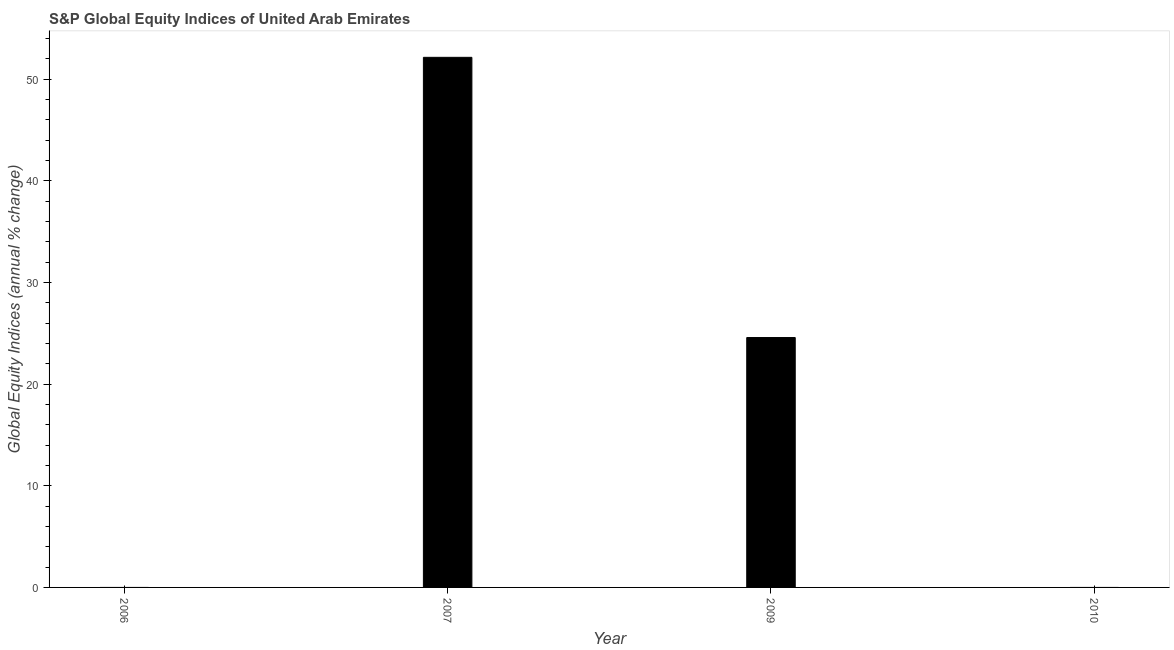Does the graph contain any zero values?
Offer a terse response. Yes. What is the title of the graph?
Your answer should be very brief. S&P Global Equity Indices of United Arab Emirates. What is the label or title of the Y-axis?
Give a very brief answer. Global Equity Indices (annual % change). What is the s&p global equity indices in 2007?
Provide a short and direct response. 52.13. Across all years, what is the maximum s&p global equity indices?
Your answer should be compact. 52.13. Across all years, what is the minimum s&p global equity indices?
Provide a short and direct response. 0. What is the sum of the s&p global equity indices?
Provide a succinct answer. 76.71. What is the difference between the s&p global equity indices in 2007 and 2009?
Provide a succinct answer. 27.56. What is the average s&p global equity indices per year?
Give a very brief answer. 19.18. What is the median s&p global equity indices?
Ensure brevity in your answer.  12.29. In how many years, is the s&p global equity indices greater than 48 %?
Give a very brief answer. 1. What is the ratio of the s&p global equity indices in 2007 to that in 2009?
Provide a short and direct response. 2.12. Is the sum of the s&p global equity indices in 2007 and 2009 greater than the maximum s&p global equity indices across all years?
Your answer should be compact. Yes. What is the difference between the highest and the lowest s&p global equity indices?
Offer a terse response. 52.13. How many years are there in the graph?
Your answer should be compact. 4. What is the Global Equity Indices (annual % change) in 2007?
Ensure brevity in your answer.  52.13. What is the Global Equity Indices (annual % change) of 2009?
Provide a short and direct response. 24.57. What is the difference between the Global Equity Indices (annual % change) in 2007 and 2009?
Keep it short and to the point. 27.56. What is the ratio of the Global Equity Indices (annual % change) in 2007 to that in 2009?
Offer a terse response. 2.12. 